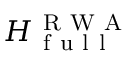Convert formula to latex. <formula><loc_0><loc_0><loc_500><loc_500>H _ { f u l l } ^ { R W A }</formula> 